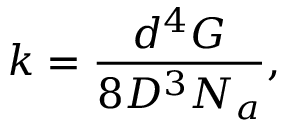<formula> <loc_0><loc_0><loc_500><loc_500>k = \frac { d ^ { 4 } G } { 8 D ^ { 3 } N _ { a } } ,</formula> 